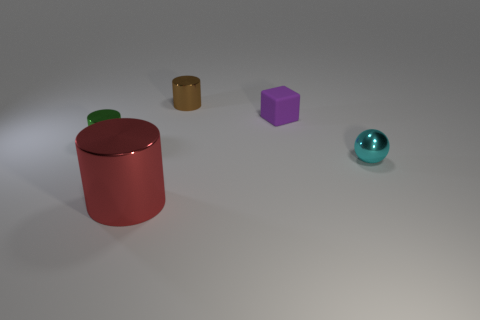Add 5 gray cylinders. How many objects exist? 10 Subtract all cylinders. How many objects are left? 2 Add 1 cubes. How many cubes are left? 2 Add 4 small objects. How many small objects exist? 8 Subtract 0 green blocks. How many objects are left? 5 Subtract all big cyan shiny cylinders. Subtract all green metal objects. How many objects are left? 4 